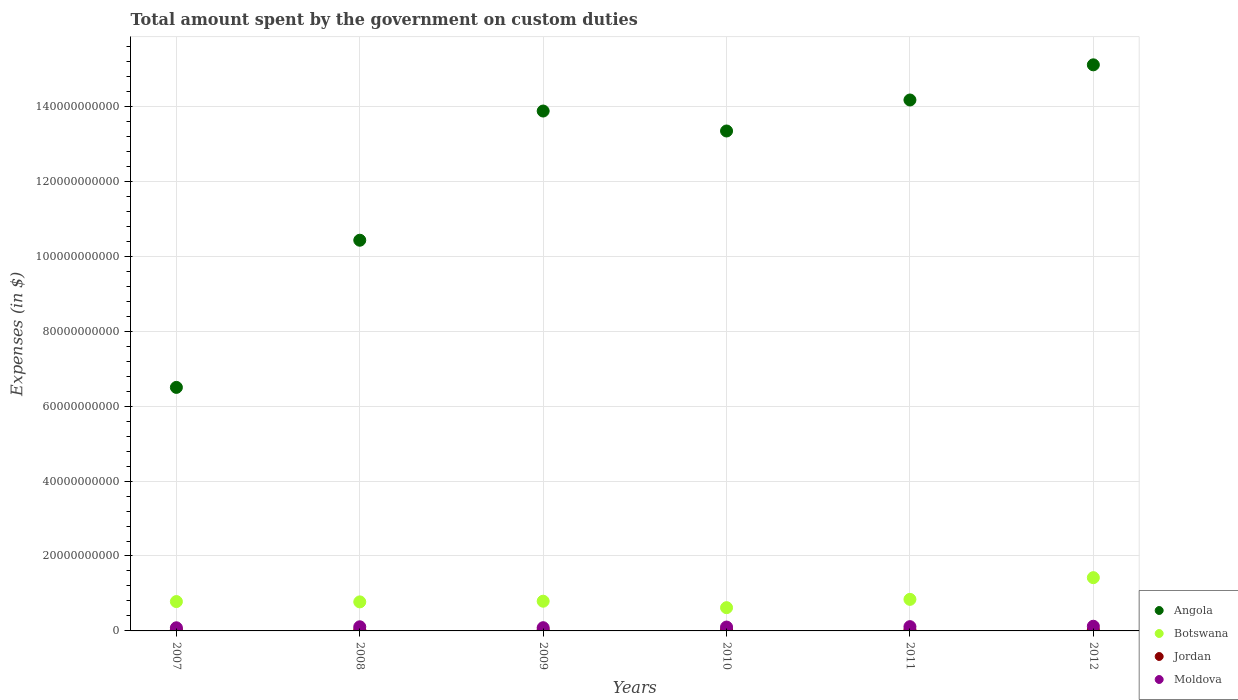Is the number of dotlines equal to the number of legend labels?
Offer a terse response. Yes. What is the amount spent on custom duties by the government in Moldova in 2012?
Your answer should be compact. 1.25e+09. Across all years, what is the maximum amount spent on custom duties by the government in Jordan?
Make the answer very short. 3.12e+08. Across all years, what is the minimum amount spent on custom duties by the government in Botswana?
Ensure brevity in your answer.  6.21e+09. In which year was the amount spent on custom duties by the government in Moldova minimum?
Your answer should be very brief. 2007. What is the total amount spent on custom duties by the government in Botswana in the graph?
Provide a short and direct response. 5.24e+1. What is the difference between the amount spent on custom duties by the government in Moldova in 2009 and that in 2011?
Your answer should be compact. -2.80e+08. What is the difference between the amount spent on custom duties by the government in Botswana in 2012 and the amount spent on custom duties by the government in Angola in 2010?
Keep it short and to the point. -1.19e+11. What is the average amount spent on custom duties by the government in Jordan per year?
Give a very brief answer. 2.82e+08. In the year 2009, what is the difference between the amount spent on custom duties by the government in Angola and amount spent on custom duties by the government in Jordan?
Make the answer very short. 1.39e+11. What is the ratio of the amount spent on custom duties by the government in Angola in 2007 to that in 2008?
Offer a very short reply. 0.62. Is the difference between the amount spent on custom duties by the government in Angola in 2010 and 2011 greater than the difference between the amount spent on custom duties by the government in Jordan in 2010 and 2011?
Offer a very short reply. No. What is the difference between the highest and the second highest amount spent on custom duties by the government in Botswana?
Make the answer very short. 5.79e+09. What is the difference between the highest and the lowest amount spent on custom duties by the government in Jordan?
Ensure brevity in your answer.  4.18e+07. Is the sum of the amount spent on custom duties by the government in Botswana in 2007 and 2012 greater than the maximum amount spent on custom duties by the government in Moldova across all years?
Offer a very short reply. Yes. Is it the case that in every year, the sum of the amount spent on custom duties by the government in Botswana and amount spent on custom duties by the government in Jordan  is greater than the amount spent on custom duties by the government in Moldova?
Your answer should be very brief. Yes. Does the amount spent on custom duties by the government in Botswana monotonically increase over the years?
Keep it short and to the point. No. Is the amount spent on custom duties by the government in Jordan strictly greater than the amount spent on custom duties by the government in Botswana over the years?
Your response must be concise. No. Is the amount spent on custom duties by the government in Moldova strictly less than the amount spent on custom duties by the government in Botswana over the years?
Provide a succinct answer. Yes. How many dotlines are there?
Your response must be concise. 4. How many years are there in the graph?
Offer a terse response. 6. What is the difference between two consecutive major ticks on the Y-axis?
Your answer should be compact. 2.00e+1. Are the values on the major ticks of Y-axis written in scientific E-notation?
Ensure brevity in your answer.  No. Does the graph contain any zero values?
Make the answer very short. No. Does the graph contain grids?
Give a very brief answer. Yes. Where does the legend appear in the graph?
Your answer should be very brief. Bottom right. How many legend labels are there?
Ensure brevity in your answer.  4. How are the legend labels stacked?
Provide a short and direct response. Vertical. What is the title of the graph?
Provide a succinct answer. Total amount spent by the government on custom duties. What is the label or title of the Y-axis?
Offer a very short reply. Expenses (in $). What is the Expenses (in $) in Angola in 2007?
Provide a short and direct response. 6.50e+1. What is the Expenses (in $) in Botswana in 2007?
Keep it short and to the point. 7.83e+09. What is the Expenses (in $) in Jordan in 2007?
Ensure brevity in your answer.  3.12e+08. What is the Expenses (in $) in Moldova in 2007?
Keep it short and to the point. 8.38e+08. What is the Expenses (in $) of Angola in 2008?
Give a very brief answer. 1.04e+11. What is the Expenses (in $) of Botswana in 2008?
Provide a succinct answer. 7.75e+09. What is the Expenses (in $) of Jordan in 2008?
Keep it short and to the point. 2.84e+08. What is the Expenses (in $) of Moldova in 2008?
Your answer should be compact. 1.10e+09. What is the Expenses (in $) in Angola in 2009?
Give a very brief answer. 1.39e+11. What is the Expenses (in $) in Botswana in 2009?
Keep it short and to the point. 7.93e+09. What is the Expenses (in $) of Jordan in 2009?
Make the answer very short. 2.70e+08. What is the Expenses (in $) in Moldova in 2009?
Your response must be concise. 8.60e+08. What is the Expenses (in $) of Angola in 2010?
Provide a short and direct response. 1.33e+11. What is the Expenses (in $) of Botswana in 2010?
Provide a short and direct response. 6.21e+09. What is the Expenses (in $) in Jordan in 2010?
Keep it short and to the point. 2.75e+08. What is the Expenses (in $) of Moldova in 2010?
Keep it short and to the point. 1.03e+09. What is the Expenses (in $) in Angola in 2011?
Keep it short and to the point. 1.42e+11. What is the Expenses (in $) of Botswana in 2011?
Your answer should be very brief. 8.42e+09. What is the Expenses (in $) of Jordan in 2011?
Ensure brevity in your answer.  2.74e+08. What is the Expenses (in $) of Moldova in 2011?
Your answer should be compact. 1.14e+09. What is the Expenses (in $) of Angola in 2012?
Ensure brevity in your answer.  1.51e+11. What is the Expenses (in $) in Botswana in 2012?
Offer a terse response. 1.42e+1. What is the Expenses (in $) of Jordan in 2012?
Offer a very short reply. 2.73e+08. What is the Expenses (in $) in Moldova in 2012?
Offer a very short reply. 1.25e+09. Across all years, what is the maximum Expenses (in $) of Angola?
Your response must be concise. 1.51e+11. Across all years, what is the maximum Expenses (in $) in Botswana?
Ensure brevity in your answer.  1.42e+1. Across all years, what is the maximum Expenses (in $) of Jordan?
Offer a terse response. 3.12e+08. Across all years, what is the maximum Expenses (in $) of Moldova?
Offer a very short reply. 1.25e+09. Across all years, what is the minimum Expenses (in $) in Angola?
Provide a short and direct response. 6.50e+1. Across all years, what is the minimum Expenses (in $) in Botswana?
Ensure brevity in your answer.  6.21e+09. Across all years, what is the minimum Expenses (in $) in Jordan?
Provide a short and direct response. 2.70e+08. Across all years, what is the minimum Expenses (in $) of Moldova?
Ensure brevity in your answer.  8.38e+08. What is the total Expenses (in $) in Angola in the graph?
Make the answer very short. 7.34e+11. What is the total Expenses (in $) of Botswana in the graph?
Offer a very short reply. 5.24e+1. What is the total Expenses (in $) of Jordan in the graph?
Offer a terse response. 1.69e+09. What is the total Expenses (in $) in Moldova in the graph?
Offer a terse response. 6.22e+09. What is the difference between the Expenses (in $) of Angola in 2007 and that in 2008?
Provide a short and direct response. -3.93e+1. What is the difference between the Expenses (in $) of Botswana in 2007 and that in 2008?
Provide a succinct answer. 8.47e+07. What is the difference between the Expenses (in $) in Jordan in 2007 and that in 2008?
Your answer should be very brief. 2.77e+07. What is the difference between the Expenses (in $) of Moldova in 2007 and that in 2008?
Offer a very short reply. -2.66e+08. What is the difference between the Expenses (in $) in Angola in 2007 and that in 2009?
Offer a terse response. -7.38e+1. What is the difference between the Expenses (in $) in Botswana in 2007 and that in 2009?
Ensure brevity in your answer.  -9.62e+07. What is the difference between the Expenses (in $) of Jordan in 2007 and that in 2009?
Provide a short and direct response. 4.18e+07. What is the difference between the Expenses (in $) of Moldova in 2007 and that in 2009?
Provide a short and direct response. -2.17e+07. What is the difference between the Expenses (in $) of Angola in 2007 and that in 2010?
Offer a terse response. -6.84e+1. What is the difference between the Expenses (in $) in Botswana in 2007 and that in 2010?
Provide a succinct answer. 1.63e+09. What is the difference between the Expenses (in $) of Jordan in 2007 and that in 2010?
Your answer should be compact. 3.69e+07. What is the difference between the Expenses (in $) of Moldova in 2007 and that in 2010?
Your answer should be compact. -1.94e+08. What is the difference between the Expenses (in $) of Angola in 2007 and that in 2011?
Your answer should be compact. -7.67e+1. What is the difference between the Expenses (in $) of Botswana in 2007 and that in 2011?
Your response must be concise. -5.89e+08. What is the difference between the Expenses (in $) in Jordan in 2007 and that in 2011?
Provide a short and direct response. 3.79e+07. What is the difference between the Expenses (in $) of Moldova in 2007 and that in 2011?
Make the answer very short. -3.02e+08. What is the difference between the Expenses (in $) in Angola in 2007 and that in 2012?
Your response must be concise. -8.61e+1. What is the difference between the Expenses (in $) of Botswana in 2007 and that in 2012?
Keep it short and to the point. -6.38e+09. What is the difference between the Expenses (in $) in Jordan in 2007 and that in 2012?
Keep it short and to the point. 3.91e+07. What is the difference between the Expenses (in $) in Moldova in 2007 and that in 2012?
Keep it short and to the point. -4.09e+08. What is the difference between the Expenses (in $) in Angola in 2008 and that in 2009?
Offer a terse response. -3.45e+1. What is the difference between the Expenses (in $) in Botswana in 2008 and that in 2009?
Your response must be concise. -1.81e+08. What is the difference between the Expenses (in $) in Jordan in 2008 and that in 2009?
Offer a very short reply. 1.41e+07. What is the difference between the Expenses (in $) in Moldova in 2008 and that in 2009?
Your response must be concise. 2.45e+08. What is the difference between the Expenses (in $) of Angola in 2008 and that in 2010?
Your response must be concise. -2.92e+1. What is the difference between the Expenses (in $) of Botswana in 2008 and that in 2010?
Make the answer very short. 1.54e+09. What is the difference between the Expenses (in $) of Jordan in 2008 and that in 2010?
Keep it short and to the point. 9.20e+06. What is the difference between the Expenses (in $) in Moldova in 2008 and that in 2010?
Keep it short and to the point. 7.22e+07. What is the difference between the Expenses (in $) in Angola in 2008 and that in 2011?
Offer a terse response. -3.74e+1. What is the difference between the Expenses (in $) of Botswana in 2008 and that in 2011?
Your answer should be compact. -6.74e+08. What is the difference between the Expenses (in $) in Jordan in 2008 and that in 2011?
Give a very brief answer. 1.02e+07. What is the difference between the Expenses (in $) in Moldova in 2008 and that in 2011?
Provide a succinct answer. -3.57e+07. What is the difference between the Expenses (in $) of Angola in 2008 and that in 2012?
Your response must be concise. -4.68e+1. What is the difference between the Expenses (in $) of Botswana in 2008 and that in 2012?
Make the answer very short. -6.47e+09. What is the difference between the Expenses (in $) in Jordan in 2008 and that in 2012?
Provide a short and direct response. 1.14e+07. What is the difference between the Expenses (in $) in Moldova in 2008 and that in 2012?
Make the answer very short. -1.43e+08. What is the difference between the Expenses (in $) in Angola in 2009 and that in 2010?
Your answer should be compact. 5.33e+09. What is the difference between the Expenses (in $) in Botswana in 2009 and that in 2010?
Provide a succinct answer. 1.72e+09. What is the difference between the Expenses (in $) of Jordan in 2009 and that in 2010?
Give a very brief answer. -4.90e+06. What is the difference between the Expenses (in $) of Moldova in 2009 and that in 2010?
Offer a terse response. -1.73e+08. What is the difference between the Expenses (in $) of Angola in 2009 and that in 2011?
Provide a short and direct response. -2.95e+09. What is the difference between the Expenses (in $) of Botswana in 2009 and that in 2011?
Your answer should be very brief. -4.93e+08. What is the difference between the Expenses (in $) of Jordan in 2009 and that in 2011?
Offer a very short reply. -3.90e+06. What is the difference between the Expenses (in $) of Moldova in 2009 and that in 2011?
Offer a very short reply. -2.80e+08. What is the difference between the Expenses (in $) of Angola in 2009 and that in 2012?
Your response must be concise. -1.23e+1. What is the difference between the Expenses (in $) in Botswana in 2009 and that in 2012?
Ensure brevity in your answer.  -6.29e+09. What is the difference between the Expenses (in $) in Jordan in 2009 and that in 2012?
Make the answer very short. -2.70e+06. What is the difference between the Expenses (in $) in Moldova in 2009 and that in 2012?
Give a very brief answer. -3.87e+08. What is the difference between the Expenses (in $) in Angola in 2010 and that in 2011?
Give a very brief answer. -8.27e+09. What is the difference between the Expenses (in $) in Botswana in 2010 and that in 2011?
Your answer should be very brief. -2.22e+09. What is the difference between the Expenses (in $) of Moldova in 2010 and that in 2011?
Provide a short and direct response. -1.08e+08. What is the difference between the Expenses (in $) of Angola in 2010 and that in 2012?
Ensure brevity in your answer.  -1.77e+1. What is the difference between the Expenses (in $) in Botswana in 2010 and that in 2012?
Offer a terse response. -8.01e+09. What is the difference between the Expenses (in $) of Jordan in 2010 and that in 2012?
Offer a terse response. 2.20e+06. What is the difference between the Expenses (in $) in Moldova in 2010 and that in 2012?
Provide a succinct answer. -2.15e+08. What is the difference between the Expenses (in $) of Angola in 2011 and that in 2012?
Ensure brevity in your answer.  -9.39e+09. What is the difference between the Expenses (in $) of Botswana in 2011 and that in 2012?
Offer a terse response. -5.79e+09. What is the difference between the Expenses (in $) in Jordan in 2011 and that in 2012?
Provide a succinct answer. 1.20e+06. What is the difference between the Expenses (in $) in Moldova in 2011 and that in 2012?
Your answer should be compact. -1.07e+08. What is the difference between the Expenses (in $) in Angola in 2007 and the Expenses (in $) in Botswana in 2008?
Ensure brevity in your answer.  5.73e+1. What is the difference between the Expenses (in $) in Angola in 2007 and the Expenses (in $) in Jordan in 2008?
Provide a succinct answer. 6.47e+1. What is the difference between the Expenses (in $) in Angola in 2007 and the Expenses (in $) in Moldova in 2008?
Give a very brief answer. 6.39e+1. What is the difference between the Expenses (in $) in Botswana in 2007 and the Expenses (in $) in Jordan in 2008?
Offer a terse response. 7.55e+09. What is the difference between the Expenses (in $) of Botswana in 2007 and the Expenses (in $) of Moldova in 2008?
Offer a terse response. 6.73e+09. What is the difference between the Expenses (in $) in Jordan in 2007 and the Expenses (in $) in Moldova in 2008?
Provide a succinct answer. -7.93e+08. What is the difference between the Expenses (in $) in Angola in 2007 and the Expenses (in $) in Botswana in 2009?
Keep it short and to the point. 5.71e+1. What is the difference between the Expenses (in $) in Angola in 2007 and the Expenses (in $) in Jordan in 2009?
Give a very brief answer. 6.47e+1. What is the difference between the Expenses (in $) in Angola in 2007 and the Expenses (in $) in Moldova in 2009?
Your answer should be compact. 6.41e+1. What is the difference between the Expenses (in $) in Botswana in 2007 and the Expenses (in $) in Jordan in 2009?
Give a very brief answer. 7.56e+09. What is the difference between the Expenses (in $) in Botswana in 2007 and the Expenses (in $) in Moldova in 2009?
Your response must be concise. 6.97e+09. What is the difference between the Expenses (in $) in Jordan in 2007 and the Expenses (in $) in Moldova in 2009?
Provide a succinct answer. -5.48e+08. What is the difference between the Expenses (in $) of Angola in 2007 and the Expenses (in $) of Botswana in 2010?
Ensure brevity in your answer.  5.88e+1. What is the difference between the Expenses (in $) of Angola in 2007 and the Expenses (in $) of Jordan in 2010?
Offer a very short reply. 6.47e+1. What is the difference between the Expenses (in $) in Angola in 2007 and the Expenses (in $) in Moldova in 2010?
Your answer should be very brief. 6.40e+1. What is the difference between the Expenses (in $) of Botswana in 2007 and the Expenses (in $) of Jordan in 2010?
Ensure brevity in your answer.  7.56e+09. What is the difference between the Expenses (in $) in Botswana in 2007 and the Expenses (in $) in Moldova in 2010?
Keep it short and to the point. 6.80e+09. What is the difference between the Expenses (in $) of Jordan in 2007 and the Expenses (in $) of Moldova in 2010?
Your response must be concise. -7.21e+08. What is the difference between the Expenses (in $) in Angola in 2007 and the Expenses (in $) in Botswana in 2011?
Give a very brief answer. 5.66e+1. What is the difference between the Expenses (in $) in Angola in 2007 and the Expenses (in $) in Jordan in 2011?
Make the answer very short. 6.47e+1. What is the difference between the Expenses (in $) in Angola in 2007 and the Expenses (in $) in Moldova in 2011?
Ensure brevity in your answer.  6.39e+1. What is the difference between the Expenses (in $) of Botswana in 2007 and the Expenses (in $) of Jordan in 2011?
Provide a short and direct response. 7.56e+09. What is the difference between the Expenses (in $) of Botswana in 2007 and the Expenses (in $) of Moldova in 2011?
Provide a short and direct response. 6.69e+09. What is the difference between the Expenses (in $) of Jordan in 2007 and the Expenses (in $) of Moldova in 2011?
Make the answer very short. -8.29e+08. What is the difference between the Expenses (in $) in Angola in 2007 and the Expenses (in $) in Botswana in 2012?
Your response must be concise. 5.08e+1. What is the difference between the Expenses (in $) in Angola in 2007 and the Expenses (in $) in Jordan in 2012?
Offer a terse response. 6.47e+1. What is the difference between the Expenses (in $) of Angola in 2007 and the Expenses (in $) of Moldova in 2012?
Your answer should be very brief. 6.38e+1. What is the difference between the Expenses (in $) of Botswana in 2007 and the Expenses (in $) of Jordan in 2012?
Your answer should be compact. 7.56e+09. What is the difference between the Expenses (in $) of Botswana in 2007 and the Expenses (in $) of Moldova in 2012?
Offer a terse response. 6.59e+09. What is the difference between the Expenses (in $) of Jordan in 2007 and the Expenses (in $) of Moldova in 2012?
Make the answer very short. -9.36e+08. What is the difference between the Expenses (in $) in Angola in 2008 and the Expenses (in $) in Botswana in 2009?
Your response must be concise. 9.64e+1. What is the difference between the Expenses (in $) in Angola in 2008 and the Expenses (in $) in Jordan in 2009?
Provide a short and direct response. 1.04e+11. What is the difference between the Expenses (in $) of Angola in 2008 and the Expenses (in $) of Moldova in 2009?
Offer a terse response. 1.03e+11. What is the difference between the Expenses (in $) of Botswana in 2008 and the Expenses (in $) of Jordan in 2009?
Provide a succinct answer. 7.48e+09. What is the difference between the Expenses (in $) in Botswana in 2008 and the Expenses (in $) in Moldova in 2009?
Your answer should be very brief. 6.89e+09. What is the difference between the Expenses (in $) in Jordan in 2008 and the Expenses (in $) in Moldova in 2009?
Give a very brief answer. -5.76e+08. What is the difference between the Expenses (in $) of Angola in 2008 and the Expenses (in $) of Botswana in 2010?
Your response must be concise. 9.81e+1. What is the difference between the Expenses (in $) of Angola in 2008 and the Expenses (in $) of Jordan in 2010?
Your answer should be very brief. 1.04e+11. What is the difference between the Expenses (in $) of Angola in 2008 and the Expenses (in $) of Moldova in 2010?
Offer a very short reply. 1.03e+11. What is the difference between the Expenses (in $) in Botswana in 2008 and the Expenses (in $) in Jordan in 2010?
Your answer should be compact. 7.47e+09. What is the difference between the Expenses (in $) of Botswana in 2008 and the Expenses (in $) of Moldova in 2010?
Give a very brief answer. 6.72e+09. What is the difference between the Expenses (in $) in Jordan in 2008 and the Expenses (in $) in Moldova in 2010?
Your response must be concise. -7.48e+08. What is the difference between the Expenses (in $) in Angola in 2008 and the Expenses (in $) in Botswana in 2011?
Offer a terse response. 9.59e+1. What is the difference between the Expenses (in $) in Angola in 2008 and the Expenses (in $) in Jordan in 2011?
Offer a very short reply. 1.04e+11. What is the difference between the Expenses (in $) in Angola in 2008 and the Expenses (in $) in Moldova in 2011?
Offer a very short reply. 1.03e+11. What is the difference between the Expenses (in $) of Botswana in 2008 and the Expenses (in $) of Jordan in 2011?
Make the answer very short. 7.48e+09. What is the difference between the Expenses (in $) of Botswana in 2008 and the Expenses (in $) of Moldova in 2011?
Your answer should be very brief. 6.61e+09. What is the difference between the Expenses (in $) of Jordan in 2008 and the Expenses (in $) of Moldova in 2011?
Offer a very short reply. -8.56e+08. What is the difference between the Expenses (in $) of Angola in 2008 and the Expenses (in $) of Botswana in 2012?
Keep it short and to the point. 9.01e+1. What is the difference between the Expenses (in $) in Angola in 2008 and the Expenses (in $) in Jordan in 2012?
Provide a short and direct response. 1.04e+11. What is the difference between the Expenses (in $) of Angola in 2008 and the Expenses (in $) of Moldova in 2012?
Provide a short and direct response. 1.03e+11. What is the difference between the Expenses (in $) in Botswana in 2008 and the Expenses (in $) in Jordan in 2012?
Provide a succinct answer. 7.48e+09. What is the difference between the Expenses (in $) in Botswana in 2008 and the Expenses (in $) in Moldova in 2012?
Give a very brief answer. 6.50e+09. What is the difference between the Expenses (in $) of Jordan in 2008 and the Expenses (in $) of Moldova in 2012?
Keep it short and to the point. -9.63e+08. What is the difference between the Expenses (in $) in Angola in 2009 and the Expenses (in $) in Botswana in 2010?
Your answer should be compact. 1.33e+11. What is the difference between the Expenses (in $) in Angola in 2009 and the Expenses (in $) in Jordan in 2010?
Give a very brief answer. 1.39e+11. What is the difference between the Expenses (in $) of Angola in 2009 and the Expenses (in $) of Moldova in 2010?
Your answer should be compact. 1.38e+11. What is the difference between the Expenses (in $) in Botswana in 2009 and the Expenses (in $) in Jordan in 2010?
Provide a short and direct response. 7.66e+09. What is the difference between the Expenses (in $) in Botswana in 2009 and the Expenses (in $) in Moldova in 2010?
Ensure brevity in your answer.  6.90e+09. What is the difference between the Expenses (in $) in Jordan in 2009 and the Expenses (in $) in Moldova in 2010?
Your answer should be compact. -7.62e+08. What is the difference between the Expenses (in $) of Angola in 2009 and the Expenses (in $) of Botswana in 2011?
Your answer should be compact. 1.30e+11. What is the difference between the Expenses (in $) in Angola in 2009 and the Expenses (in $) in Jordan in 2011?
Your response must be concise. 1.39e+11. What is the difference between the Expenses (in $) of Angola in 2009 and the Expenses (in $) of Moldova in 2011?
Make the answer very short. 1.38e+11. What is the difference between the Expenses (in $) of Botswana in 2009 and the Expenses (in $) of Jordan in 2011?
Offer a very short reply. 7.66e+09. What is the difference between the Expenses (in $) in Botswana in 2009 and the Expenses (in $) in Moldova in 2011?
Provide a short and direct response. 6.79e+09. What is the difference between the Expenses (in $) in Jordan in 2009 and the Expenses (in $) in Moldova in 2011?
Your answer should be very brief. -8.70e+08. What is the difference between the Expenses (in $) of Angola in 2009 and the Expenses (in $) of Botswana in 2012?
Your answer should be compact. 1.25e+11. What is the difference between the Expenses (in $) of Angola in 2009 and the Expenses (in $) of Jordan in 2012?
Make the answer very short. 1.39e+11. What is the difference between the Expenses (in $) in Angola in 2009 and the Expenses (in $) in Moldova in 2012?
Your answer should be compact. 1.38e+11. What is the difference between the Expenses (in $) in Botswana in 2009 and the Expenses (in $) in Jordan in 2012?
Keep it short and to the point. 7.66e+09. What is the difference between the Expenses (in $) in Botswana in 2009 and the Expenses (in $) in Moldova in 2012?
Provide a succinct answer. 6.68e+09. What is the difference between the Expenses (in $) of Jordan in 2009 and the Expenses (in $) of Moldova in 2012?
Ensure brevity in your answer.  -9.77e+08. What is the difference between the Expenses (in $) of Angola in 2010 and the Expenses (in $) of Botswana in 2011?
Your answer should be compact. 1.25e+11. What is the difference between the Expenses (in $) of Angola in 2010 and the Expenses (in $) of Jordan in 2011?
Ensure brevity in your answer.  1.33e+11. What is the difference between the Expenses (in $) of Angola in 2010 and the Expenses (in $) of Moldova in 2011?
Your response must be concise. 1.32e+11. What is the difference between the Expenses (in $) in Botswana in 2010 and the Expenses (in $) in Jordan in 2011?
Keep it short and to the point. 5.93e+09. What is the difference between the Expenses (in $) in Botswana in 2010 and the Expenses (in $) in Moldova in 2011?
Offer a very short reply. 5.07e+09. What is the difference between the Expenses (in $) in Jordan in 2010 and the Expenses (in $) in Moldova in 2011?
Give a very brief answer. -8.66e+08. What is the difference between the Expenses (in $) in Angola in 2010 and the Expenses (in $) in Botswana in 2012?
Keep it short and to the point. 1.19e+11. What is the difference between the Expenses (in $) in Angola in 2010 and the Expenses (in $) in Jordan in 2012?
Keep it short and to the point. 1.33e+11. What is the difference between the Expenses (in $) in Angola in 2010 and the Expenses (in $) in Moldova in 2012?
Ensure brevity in your answer.  1.32e+11. What is the difference between the Expenses (in $) in Botswana in 2010 and the Expenses (in $) in Jordan in 2012?
Your response must be concise. 5.93e+09. What is the difference between the Expenses (in $) of Botswana in 2010 and the Expenses (in $) of Moldova in 2012?
Ensure brevity in your answer.  4.96e+09. What is the difference between the Expenses (in $) of Jordan in 2010 and the Expenses (in $) of Moldova in 2012?
Make the answer very short. -9.72e+08. What is the difference between the Expenses (in $) in Angola in 2011 and the Expenses (in $) in Botswana in 2012?
Make the answer very short. 1.28e+11. What is the difference between the Expenses (in $) of Angola in 2011 and the Expenses (in $) of Jordan in 2012?
Provide a succinct answer. 1.41e+11. What is the difference between the Expenses (in $) of Angola in 2011 and the Expenses (in $) of Moldova in 2012?
Your answer should be very brief. 1.40e+11. What is the difference between the Expenses (in $) in Botswana in 2011 and the Expenses (in $) in Jordan in 2012?
Provide a short and direct response. 8.15e+09. What is the difference between the Expenses (in $) in Botswana in 2011 and the Expenses (in $) in Moldova in 2012?
Provide a succinct answer. 7.18e+09. What is the difference between the Expenses (in $) in Jordan in 2011 and the Expenses (in $) in Moldova in 2012?
Offer a very short reply. -9.73e+08. What is the average Expenses (in $) in Angola per year?
Provide a succinct answer. 1.22e+11. What is the average Expenses (in $) of Botswana per year?
Ensure brevity in your answer.  8.73e+09. What is the average Expenses (in $) of Jordan per year?
Give a very brief answer. 2.82e+08. What is the average Expenses (in $) in Moldova per year?
Keep it short and to the point. 1.04e+09. In the year 2007, what is the difference between the Expenses (in $) in Angola and Expenses (in $) in Botswana?
Give a very brief answer. 5.72e+1. In the year 2007, what is the difference between the Expenses (in $) of Angola and Expenses (in $) of Jordan?
Offer a terse response. 6.47e+1. In the year 2007, what is the difference between the Expenses (in $) in Angola and Expenses (in $) in Moldova?
Your answer should be compact. 6.42e+1. In the year 2007, what is the difference between the Expenses (in $) of Botswana and Expenses (in $) of Jordan?
Give a very brief answer. 7.52e+09. In the year 2007, what is the difference between the Expenses (in $) of Botswana and Expenses (in $) of Moldova?
Offer a terse response. 7.00e+09. In the year 2007, what is the difference between the Expenses (in $) of Jordan and Expenses (in $) of Moldova?
Offer a terse response. -5.26e+08. In the year 2008, what is the difference between the Expenses (in $) of Angola and Expenses (in $) of Botswana?
Offer a terse response. 9.65e+1. In the year 2008, what is the difference between the Expenses (in $) in Angola and Expenses (in $) in Jordan?
Offer a terse response. 1.04e+11. In the year 2008, what is the difference between the Expenses (in $) in Angola and Expenses (in $) in Moldova?
Offer a very short reply. 1.03e+11. In the year 2008, what is the difference between the Expenses (in $) of Botswana and Expenses (in $) of Jordan?
Your answer should be compact. 7.47e+09. In the year 2008, what is the difference between the Expenses (in $) of Botswana and Expenses (in $) of Moldova?
Your answer should be compact. 6.65e+09. In the year 2008, what is the difference between the Expenses (in $) of Jordan and Expenses (in $) of Moldova?
Keep it short and to the point. -8.21e+08. In the year 2009, what is the difference between the Expenses (in $) in Angola and Expenses (in $) in Botswana?
Provide a succinct answer. 1.31e+11. In the year 2009, what is the difference between the Expenses (in $) of Angola and Expenses (in $) of Jordan?
Provide a short and direct response. 1.39e+11. In the year 2009, what is the difference between the Expenses (in $) in Angola and Expenses (in $) in Moldova?
Your answer should be compact. 1.38e+11. In the year 2009, what is the difference between the Expenses (in $) of Botswana and Expenses (in $) of Jordan?
Provide a short and direct response. 7.66e+09. In the year 2009, what is the difference between the Expenses (in $) in Botswana and Expenses (in $) in Moldova?
Provide a short and direct response. 7.07e+09. In the year 2009, what is the difference between the Expenses (in $) in Jordan and Expenses (in $) in Moldova?
Offer a terse response. -5.90e+08. In the year 2010, what is the difference between the Expenses (in $) of Angola and Expenses (in $) of Botswana?
Provide a short and direct response. 1.27e+11. In the year 2010, what is the difference between the Expenses (in $) of Angola and Expenses (in $) of Jordan?
Provide a short and direct response. 1.33e+11. In the year 2010, what is the difference between the Expenses (in $) in Angola and Expenses (in $) in Moldova?
Your answer should be very brief. 1.32e+11. In the year 2010, what is the difference between the Expenses (in $) in Botswana and Expenses (in $) in Jordan?
Provide a succinct answer. 5.93e+09. In the year 2010, what is the difference between the Expenses (in $) of Botswana and Expenses (in $) of Moldova?
Provide a short and direct response. 5.17e+09. In the year 2010, what is the difference between the Expenses (in $) of Jordan and Expenses (in $) of Moldova?
Provide a short and direct response. -7.58e+08. In the year 2011, what is the difference between the Expenses (in $) in Angola and Expenses (in $) in Botswana?
Ensure brevity in your answer.  1.33e+11. In the year 2011, what is the difference between the Expenses (in $) in Angola and Expenses (in $) in Jordan?
Offer a very short reply. 1.41e+11. In the year 2011, what is the difference between the Expenses (in $) of Angola and Expenses (in $) of Moldova?
Offer a terse response. 1.41e+11. In the year 2011, what is the difference between the Expenses (in $) in Botswana and Expenses (in $) in Jordan?
Provide a short and direct response. 8.15e+09. In the year 2011, what is the difference between the Expenses (in $) of Botswana and Expenses (in $) of Moldova?
Offer a very short reply. 7.28e+09. In the year 2011, what is the difference between the Expenses (in $) in Jordan and Expenses (in $) in Moldova?
Your response must be concise. -8.66e+08. In the year 2012, what is the difference between the Expenses (in $) of Angola and Expenses (in $) of Botswana?
Offer a very short reply. 1.37e+11. In the year 2012, what is the difference between the Expenses (in $) of Angola and Expenses (in $) of Jordan?
Give a very brief answer. 1.51e+11. In the year 2012, what is the difference between the Expenses (in $) of Angola and Expenses (in $) of Moldova?
Keep it short and to the point. 1.50e+11. In the year 2012, what is the difference between the Expenses (in $) in Botswana and Expenses (in $) in Jordan?
Offer a very short reply. 1.39e+1. In the year 2012, what is the difference between the Expenses (in $) in Botswana and Expenses (in $) in Moldova?
Offer a very short reply. 1.30e+1. In the year 2012, what is the difference between the Expenses (in $) of Jordan and Expenses (in $) of Moldova?
Offer a terse response. -9.75e+08. What is the ratio of the Expenses (in $) in Angola in 2007 to that in 2008?
Offer a terse response. 0.62. What is the ratio of the Expenses (in $) of Botswana in 2007 to that in 2008?
Your response must be concise. 1.01. What is the ratio of the Expenses (in $) in Jordan in 2007 to that in 2008?
Provide a succinct answer. 1.1. What is the ratio of the Expenses (in $) in Moldova in 2007 to that in 2008?
Ensure brevity in your answer.  0.76. What is the ratio of the Expenses (in $) in Angola in 2007 to that in 2009?
Your answer should be compact. 0.47. What is the ratio of the Expenses (in $) in Botswana in 2007 to that in 2009?
Ensure brevity in your answer.  0.99. What is the ratio of the Expenses (in $) in Jordan in 2007 to that in 2009?
Offer a terse response. 1.15. What is the ratio of the Expenses (in $) of Moldova in 2007 to that in 2009?
Make the answer very short. 0.97. What is the ratio of the Expenses (in $) of Angola in 2007 to that in 2010?
Ensure brevity in your answer.  0.49. What is the ratio of the Expenses (in $) of Botswana in 2007 to that in 2010?
Give a very brief answer. 1.26. What is the ratio of the Expenses (in $) of Jordan in 2007 to that in 2010?
Make the answer very short. 1.13. What is the ratio of the Expenses (in $) of Moldova in 2007 to that in 2010?
Your answer should be very brief. 0.81. What is the ratio of the Expenses (in $) in Angola in 2007 to that in 2011?
Your answer should be compact. 0.46. What is the ratio of the Expenses (in $) in Botswana in 2007 to that in 2011?
Provide a succinct answer. 0.93. What is the ratio of the Expenses (in $) of Jordan in 2007 to that in 2011?
Give a very brief answer. 1.14. What is the ratio of the Expenses (in $) of Moldova in 2007 to that in 2011?
Offer a terse response. 0.74. What is the ratio of the Expenses (in $) in Angola in 2007 to that in 2012?
Give a very brief answer. 0.43. What is the ratio of the Expenses (in $) in Botswana in 2007 to that in 2012?
Make the answer very short. 0.55. What is the ratio of the Expenses (in $) in Jordan in 2007 to that in 2012?
Offer a very short reply. 1.14. What is the ratio of the Expenses (in $) in Moldova in 2007 to that in 2012?
Provide a succinct answer. 0.67. What is the ratio of the Expenses (in $) in Angola in 2008 to that in 2009?
Provide a short and direct response. 0.75. What is the ratio of the Expenses (in $) of Botswana in 2008 to that in 2009?
Keep it short and to the point. 0.98. What is the ratio of the Expenses (in $) in Jordan in 2008 to that in 2009?
Your response must be concise. 1.05. What is the ratio of the Expenses (in $) in Moldova in 2008 to that in 2009?
Offer a very short reply. 1.28. What is the ratio of the Expenses (in $) of Angola in 2008 to that in 2010?
Offer a terse response. 0.78. What is the ratio of the Expenses (in $) in Botswana in 2008 to that in 2010?
Provide a short and direct response. 1.25. What is the ratio of the Expenses (in $) in Jordan in 2008 to that in 2010?
Offer a very short reply. 1.03. What is the ratio of the Expenses (in $) in Moldova in 2008 to that in 2010?
Ensure brevity in your answer.  1.07. What is the ratio of the Expenses (in $) of Angola in 2008 to that in 2011?
Give a very brief answer. 0.74. What is the ratio of the Expenses (in $) in Jordan in 2008 to that in 2011?
Provide a succinct answer. 1.04. What is the ratio of the Expenses (in $) of Moldova in 2008 to that in 2011?
Your answer should be compact. 0.97. What is the ratio of the Expenses (in $) in Angola in 2008 to that in 2012?
Offer a terse response. 0.69. What is the ratio of the Expenses (in $) of Botswana in 2008 to that in 2012?
Your response must be concise. 0.55. What is the ratio of the Expenses (in $) in Jordan in 2008 to that in 2012?
Provide a short and direct response. 1.04. What is the ratio of the Expenses (in $) of Moldova in 2008 to that in 2012?
Offer a very short reply. 0.89. What is the ratio of the Expenses (in $) in Angola in 2009 to that in 2010?
Provide a succinct answer. 1.04. What is the ratio of the Expenses (in $) of Botswana in 2009 to that in 2010?
Provide a short and direct response. 1.28. What is the ratio of the Expenses (in $) of Jordan in 2009 to that in 2010?
Ensure brevity in your answer.  0.98. What is the ratio of the Expenses (in $) in Moldova in 2009 to that in 2010?
Make the answer very short. 0.83. What is the ratio of the Expenses (in $) in Angola in 2009 to that in 2011?
Keep it short and to the point. 0.98. What is the ratio of the Expenses (in $) in Botswana in 2009 to that in 2011?
Keep it short and to the point. 0.94. What is the ratio of the Expenses (in $) of Jordan in 2009 to that in 2011?
Provide a succinct answer. 0.99. What is the ratio of the Expenses (in $) in Moldova in 2009 to that in 2011?
Your answer should be compact. 0.75. What is the ratio of the Expenses (in $) in Angola in 2009 to that in 2012?
Provide a succinct answer. 0.92. What is the ratio of the Expenses (in $) in Botswana in 2009 to that in 2012?
Keep it short and to the point. 0.56. What is the ratio of the Expenses (in $) of Moldova in 2009 to that in 2012?
Offer a very short reply. 0.69. What is the ratio of the Expenses (in $) of Angola in 2010 to that in 2011?
Offer a terse response. 0.94. What is the ratio of the Expenses (in $) of Botswana in 2010 to that in 2011?
Make the answer very short. 0.74. What is the ratio of the Expenses (in $) of Moldova in 2010 to that in 2011?
Give a very brief answer. 0.91. What is the ratio of the Expenses (in $) in Angola in 2010 to that in 2012?
Your answer should be very brief. 0.88. What is the ratio of the Expenses (in $) of Botswana in 2010 to that in 2012?
Provide a succinct answer. 0.44. What is the ratio of the Expenses (in $) of Moldova in 2010 to that in 2012?
Keep it short and to the point. 0.83. What is the ratio of the Expenses (in $) in Angola in 2011 to that in 2012?
Your answer should be very brief. 0.94. What is the ratio of the Expenses (in $) of Botswana in 2011 to that in 2012?
Offer a very short reply. 0.59. What is the ratio of the Expenses (in $) in Jordan in 2011 to that in 2012?
Your answer should be compact. 1. What is the ratio of the Expenses (in $) in Moldova in 2011 to that in 2012?
Provide a short and direct response. 0.91. What is the difference between the highest and the second highest Expenses (in $) of Angola?
Your answer should be compact. 9.39e+09. What is the difference between the highest and the second highest Expenses (in $) of Botswana?
Give a very brief answer. 5.79e+09. What is the difference between the highest and the second highest Expenses (in $) in Jordan?
Your response must be concise. 2.77e+07. What is the difference between the highest and the second highest Expenses (in $) of Moldova?
Offer a terse response. 1.07e+08. What is the difference between the highest and the lowest Expenses (in $) of Angola?
Your answer should be very brief. 8.61e+1. What is the difference between the highest and the lowest Expenses (in $) in Botswana?
Your answer should be compact. 8.01e+09. What is the difference between the highest and the lowest Expenses (in $) of Jordan?
Offer a terse response. 4.18e+07. What is the difference between the highest and the lowest Expenses (in $) of Moldova?
Ensure brevity in your answer.  4.09e+08. 